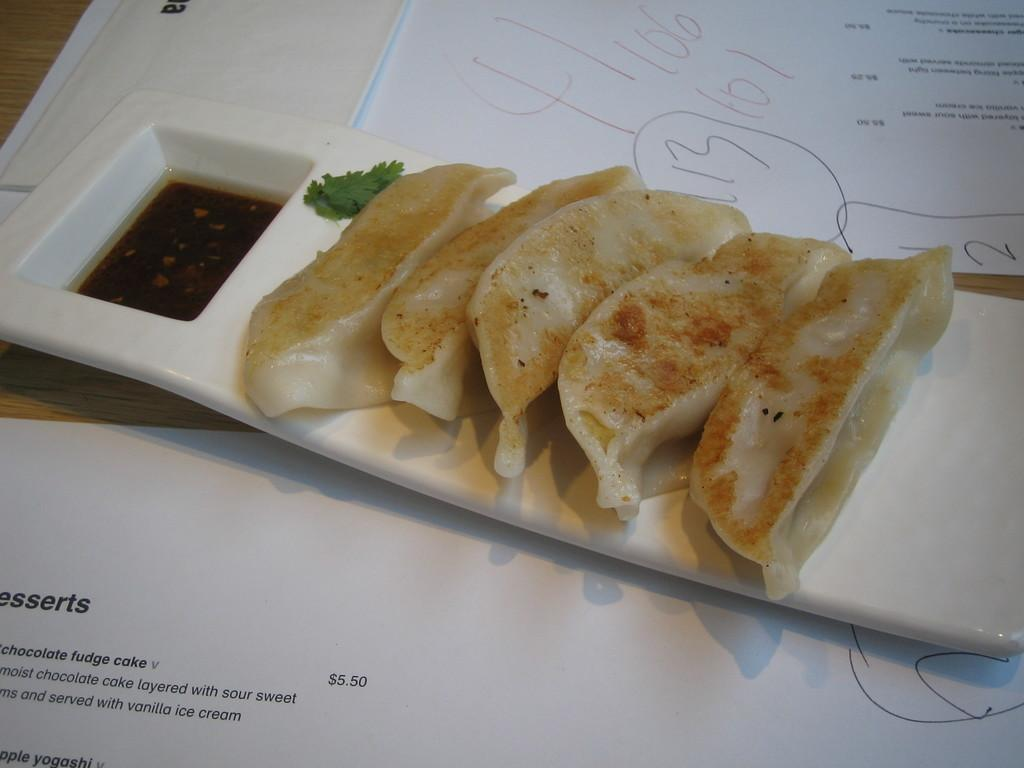What is on the plate in the image? There are food items on a plate in the image. What color is the plate? The plate is white in color. What else can be seen at the bottom of the image? There are papers at the bottom of the image. Can you see a rabbit pointing towards the railway in the image? There is no rabbit or railway present in the image. 